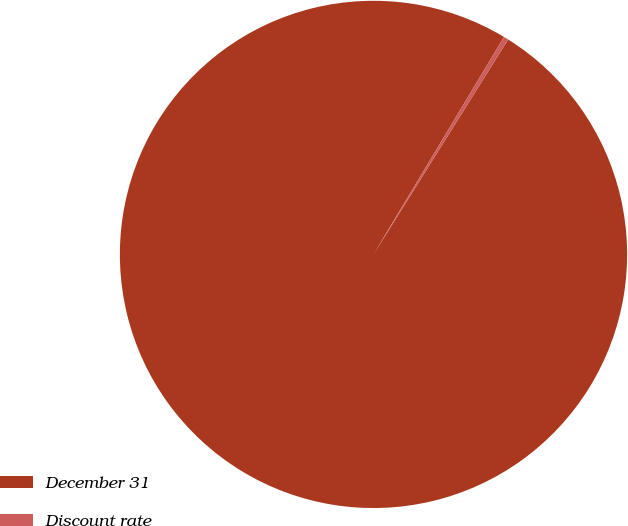Convert chart. <chart><loc_0><loc_0><loc_500><loc_500><pie_chart><fcel>December 31<fcel>Discount rate<nl><fcel>99.69%<fcel>0.31%<nl></chart> 